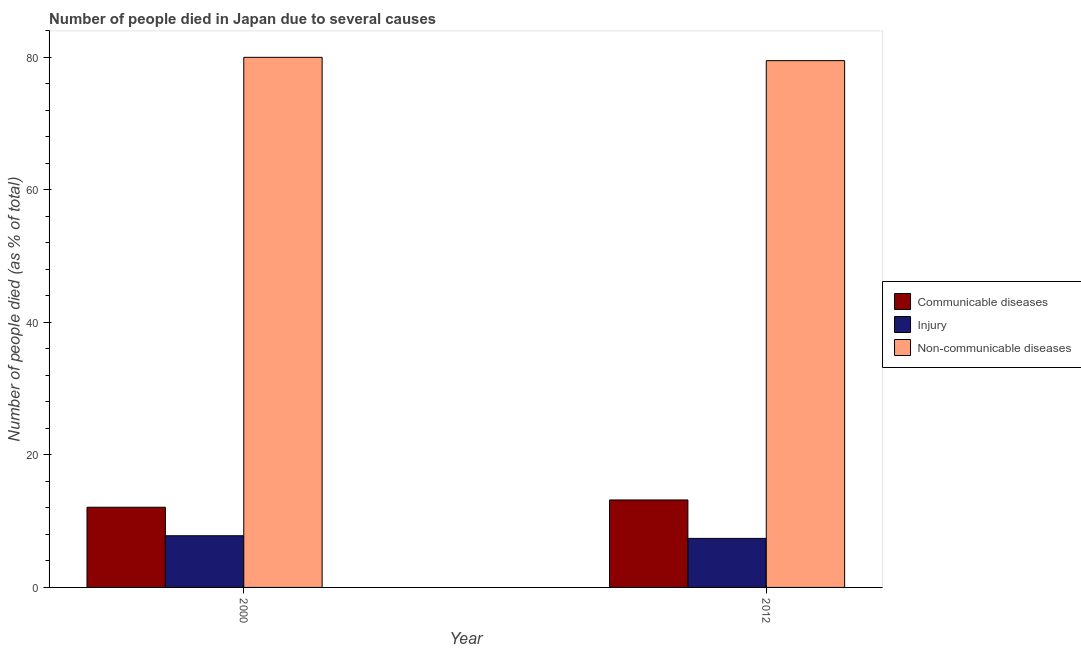How many different coloured bars are there?
Your response must be concise. 3. Are the number of bars on each tick of the X-axis equal?
Offer a very short reply. Yes. What is the label of the 1st group of bars from the left?
Your answer should be very brief. 2000. Across all years, what is the minimum number of people who dies of non-communicable diseases?
Your response must be concise. 79.5. In which year was the number of people who dies of non-communicable diseases minimum?
Provide a short and direct response. 2012. What is the total number of people who died of communicable diseases in the graph?
Ensure brevity in your answer.  25.3. What is the difference between the number of people who died of injury in 2000 and that in 2012?
Keep it short and to the point. 0.4. What is the difference between the number of people who died of communicable diseases in 2000 and the number of people who died of injury in 2012?
Keep it short and to the point. -1.1. What is the average number of people who dies of non-communicable diseases per year?
Offer a terse response. 79.75. In the year 2012, what is the difference between the number of people who died of communicable diseases and number of people who dies of non-communicable diseases?
Ensure brevity in your answer.  0. In how many years, is the number of people who died of injury greater than 64 %?
Make the answer very short. 0. What is the ratio of the number of people who died of injury in 2000 to that in 2012?
Make the answer very short. 1.05. Is the number of people who dies of non-communicable diseases in 2000 less than that in 2012?
Make the answer very short. No. What does the 1st bar from the left in 2012 represents?
Give a very brief answer. Communicable diseases. What does the 3rd bar from the right in 2012 represents?
Offer a terse response. Communicable diseases. Is it the case that in every year, the sum of the number of people who died of communicable diseases and number of people who died of injury is greater than the number of people who dies of non-communicable diseases?
Give a very brief answer. No. How many years are there in the graph?
Your answer should be compact. 2. Are the values on the major ticks of Y-axis written in scientific E-notation?
Keep it short and to the point. No. Does the graph contain any zero values?
Provide a succinct answer. No. Does the graph contain grids?
Keep it short and to the point. No. Where does the legend appear in the graph?
Provide a short and direct response. Center right. How many legend labels are there?
Your answer should be very brief. 3. How are the legend labels stacked?
Provide a short and direct response. Vertical. What is the title of the graph?
Give a very brief answer. Number of people died in Japan due to several causes. Does "Maunufacturing" appear as one of the legend labels in the graph?
Provide a succinct answer. No. What is the label or title of the Y-axis?
Your response must be concise. Number of people died (as % of total). What is the Number of people died (as % of total) of Communicable diseases in 2000?
Make the answer very short. 12.1. What is the Number of people died (as % of total) of Non-communicable diseases in 2000?
Your answer should be very brief. 80. What is the Number of people died (as % of total) of Injury in 2012?
Provide a succinct answer. 7.4. What is the Number of people died (as % of total) of Non-communicable diseases in 2012?
Give a very brief answer. 79.5. Across all years, what is the maximum Number of people died (as % of total) in Communicable diseases?
Make the answer very short. 13.2. Across all years, what is the maximum Number of people died (as % of total) of Non-communicable diseases?
Your answer should be very brief. 80. Across all years, what is the minimum Number of people died (as % of total) in Non-communicable diseases?
Provide a succinct answer. 79.5. What is the total Number of people died (as % of total) of Communicable diseases in the graph?
Give a very brief answer. 25.3. What is the total Number of people died (as % of total) of Injury in the graph?
Your answer should be very brief. 15.2. What is the total Number of people died (as % of total) of Non-communicable diseases in the graph?
Keep it short and to the point. 159.5. What is the difference between the Number of people died (as % of total) in Communicable diseases in 2000 and that in 2012?
Give a very brief answer. -1.1. What is the difference between the Number of people died (as % of total) of Communicable diseases in 2000 and the Number of people died (as % of total) of Non-communicable diseases in 2012?
Your response must be concise. -67.4. What is the difference between the Number of people died (as % of total) in Injury in 2000 and the Number of people died (as % of total) in Non-communicable diseases in 2012?
Your response must be concise. -71.7. What is the average Number of people died (as % of total) in Communicable diseases per year?
Your response must be concise. 12.65. What is the average Number of people died (as % of total) of Injury per year?
Ensure brevity in your answer.  7.6. What is the average Number of people died (as % of total) in Non-communicable diseases per year?
Provide a short and direct response. 79.75. In the year 2000, what is the difference between the Number of people died (as % of total) in Communicable diseases and Number of people died (as % of total) in Non-communicable diseases?
Your response must be concise. -67.9. In the year 2000, what is the difference between the Number of people died (as % of total) of Injury and Number of people died (as % of total) of Non-communicable diseases?
Offer a terse response. -72.2. In the year 2012, what is the difference between the Number of people died (as % of total) in Communicable diseases and Number of people died (as % of total) in Injury?
Your answer should be compact. 5.8. In the year 2012, what is the difference between the Number of people died (as % of total) in Communicable diseases and Number of people died (as % of total) in Non-communicable diseases?
Your response must be concise. -66.3. In the year 2012, what is the difference between the Number of people died (as % of total) of Injury and Number of people died (as % of total) of Non-communicable diseases?
Give a very brief answer. -72.1. What is the ratio of the Number of people died (as % of total) of Communicable diseases in 2000 to that in 2012?
Offer a very short reply. 0.92. What is the ratio of the Number of people died (as % of total) of Injury in 2000 to that in 2012?
Make the answer very short. 1.05. What is the ratio of the Number of people died (as % of total) in Non-communicable diseases in 2000 to that in 2012?
Your answer should be very brief. 1.01. What is the difference between the highest and the second highest Number of people died (as % of total) of Communicable diseases?
Provide a short and direct response. 1.1. What is the difference between the highest and the second highest Number of people died (as % of total) of Injury?
Ensure brevity in your answer.  0.4. What is the difference between the highest and the second highest Number of people died (as % of total) of Non-communicable diseases?
Provide a succinct answer. 0.5. What is the difference between the highest and the lowest Number of people died (as % of total) of Communicable diseases?
Offer a very short reply. 1.1. 